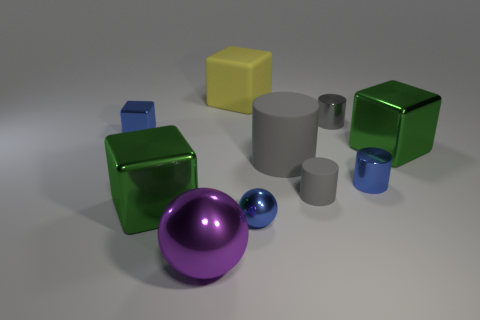Subtract all gray cylinders. How many were subtracted if there are1gray cylinders left? 2 Subtract all tiny blue metal cubes. How many cubes are left? 3 Subtract all balls. How many objects are left? 8 Subtract 1 spheres. How many spheres are left? 1 Subtract all rubber objects. Subtract all small rubber things. How many objects are left? 6 Add 6 large yellow objects. How many large yellow objects are left? 7 Add 3 large matte objects. How many large matte objects exist? 5 Subtract all green cubes. How many cubes are left? 2 Subtract 0 cyan cylinders. How many objects are left? 10 Subtract all purple spheres. Subtract all yellow cubes. How many spheres are left? 1 